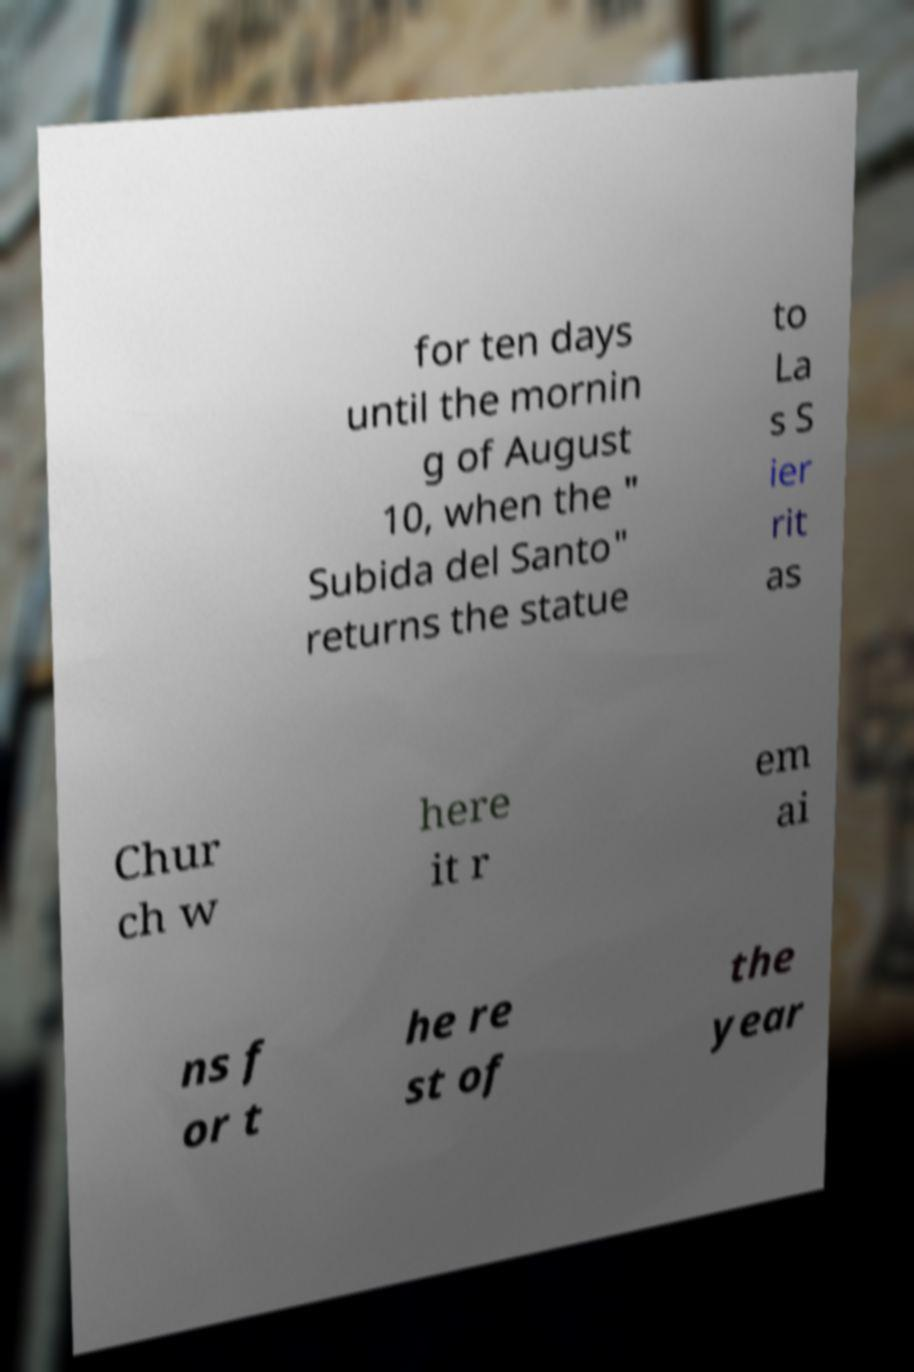Can you read and provide the text displayed in the image?This photo seems to have some interesting text. Can you extract and type it out for me? for ten days until the mornin g of August 10, when the " Subida del Santo" returns the statue to La s S ier rit as Chur ch w here it r em ai ns f or t he re st of the year 